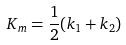Convert formula to latex. <formula><loc_0><loc_0><loc_500><loc_500>K _ { m } = \frac { 1 } { 2 } ( k _ { 1 } + k _ { 2 } )</formula> 